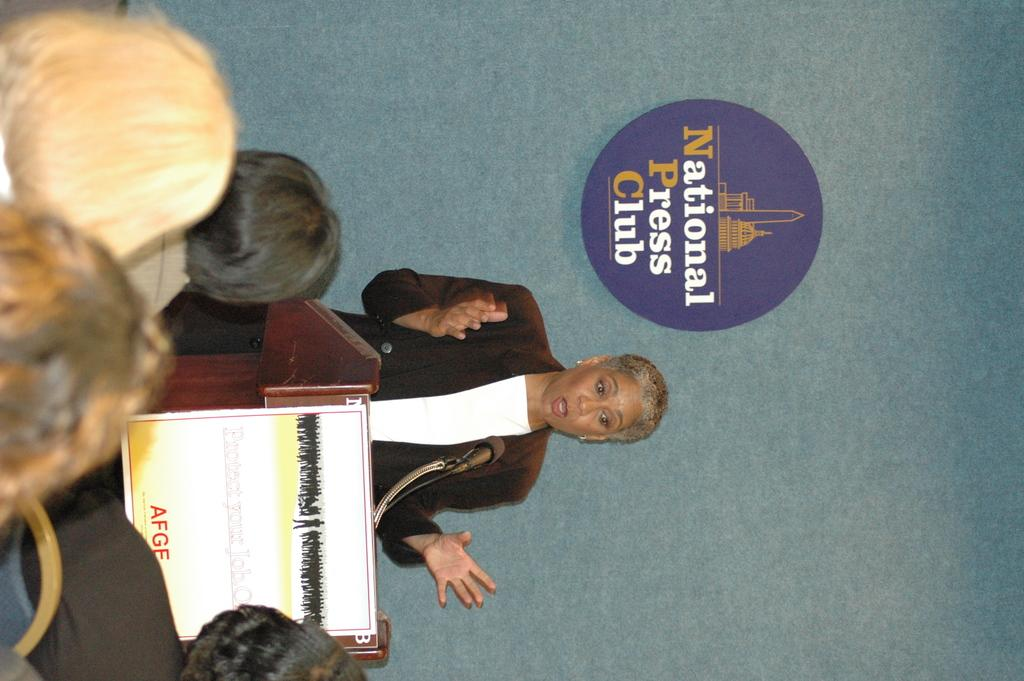What is the lady doing in the image? The lady is standing behind a bench and speaking. Who is the lady addressing in the image? There are people in front of the lady, so she might be speaking to them. What can be seen on the wall behind the lady? There is a logo on the wall behind the lady. What type of car is parked next to the lady in the image? There is no car present in the image; it only features the lady, people, and a logo on the wall. 